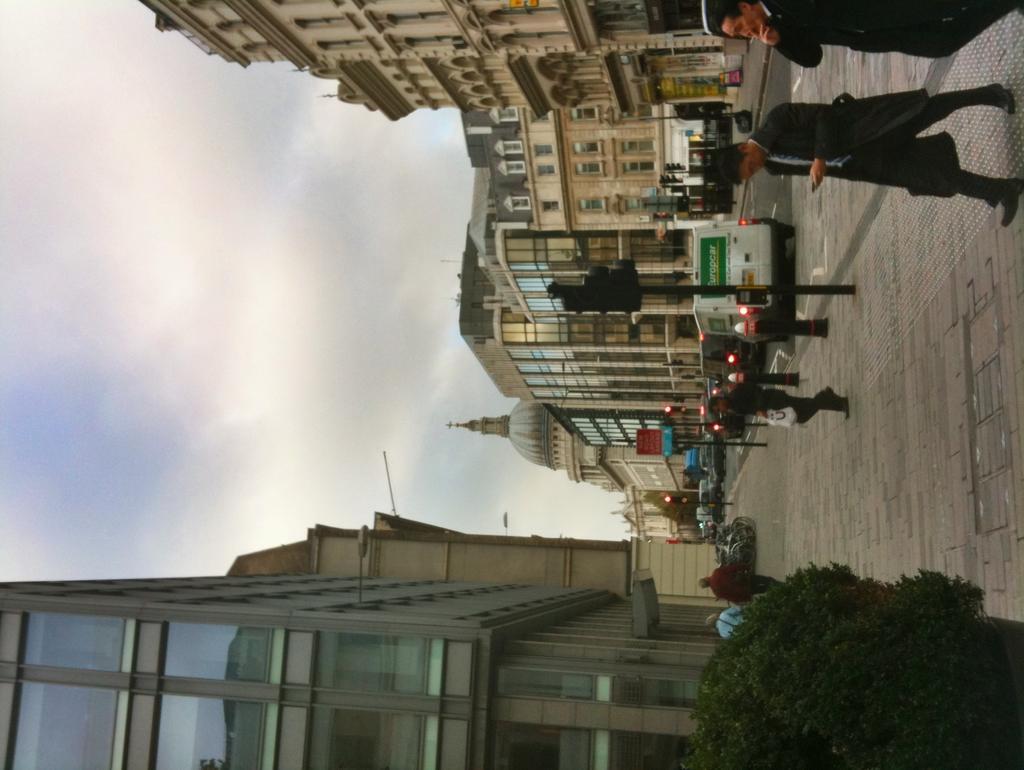Could you give a brief overview of what you see in this image? There is a plant in the bottom right corner of this image. We can see some persons and buildings on the right side of this image and there is a sky on the left side of this image. 